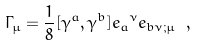<formula> <loc_0><loc_0><loc_500><loc_500>\Gamma _ { \mu } = \frac { 1 } { 8 } [ \gamma ^ { a } , \gamma ^ { b } ] { e _ { a } } ^ { \nu } e _ { b \nu ; \mu } \ ,</formula> 